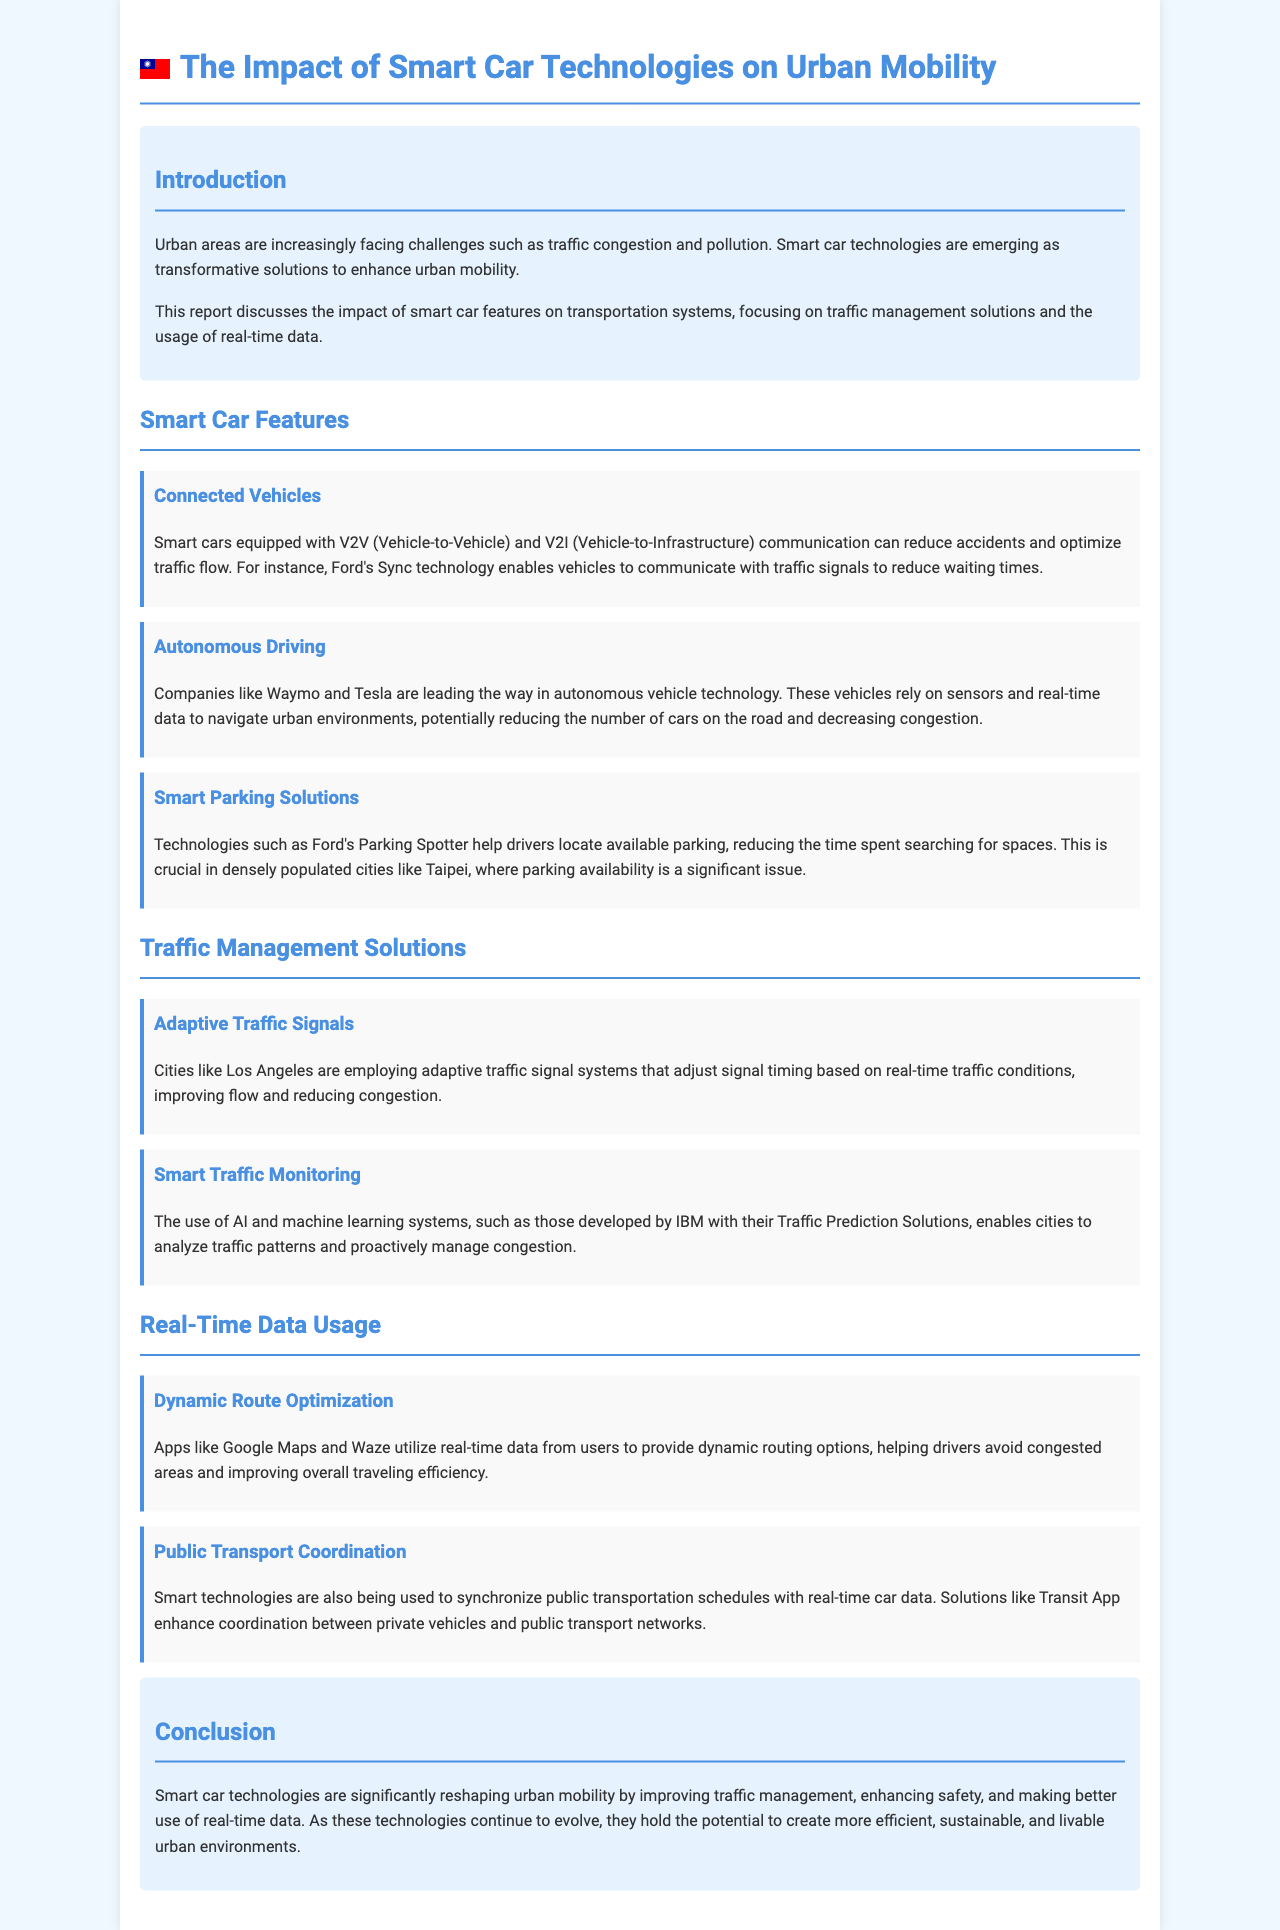What is the main focus of the report? The report discusses the impact of smart car features on transportation systems, specifically focusing on traffic management solutions and real-time data usage.
Answer: urban mobility Which smart car technology helps in reducing accidents? Connected Vehicles equipped with V2V and V2I communication optimize traffic flow and can reduce accidents.
Answer: Connected Vehicles Which city is mentioned as using adaptive traffic signals? The report mentions Los Angeles as a city employing adaptive traffic signal systems that improve flow and reduce congestion.
Answer: Los Angeles What technology helps drivers locate available parking? Ford's Parking Spotter is a technology that assists drivers in finding available parking spaces.
Answer: Ford's Parking Spotter What applications utilize real-time data for dynamic routing? Apps like Google Maps and Waze use real-time data from users to provide dynamic routing options.
Answer: Google Maps and Waze What is the potential benefit of smart car technologies mentioned in the conclusion? The report states that smart car technologies have the potential to create more efficient, sustainable, and livable urban environments.
Answer: efficient, sustainable, and livable urban environments How do smart technologies enhance public transport? Smart technologies synchronize public transportation schedules with real-time car data, improving coordination.
Answer: enhancing coordination What is the role of AI in traffic management solutions? AI and machine learning systems help analyze traffic patterns and proactively manage congestion.
Answer: analyze traffic patterns What type of data do autonomous vehicles rely on? Autonomous vehicles rely on sensors and real-time data to navigate urban environments.
Answer: real-time data 